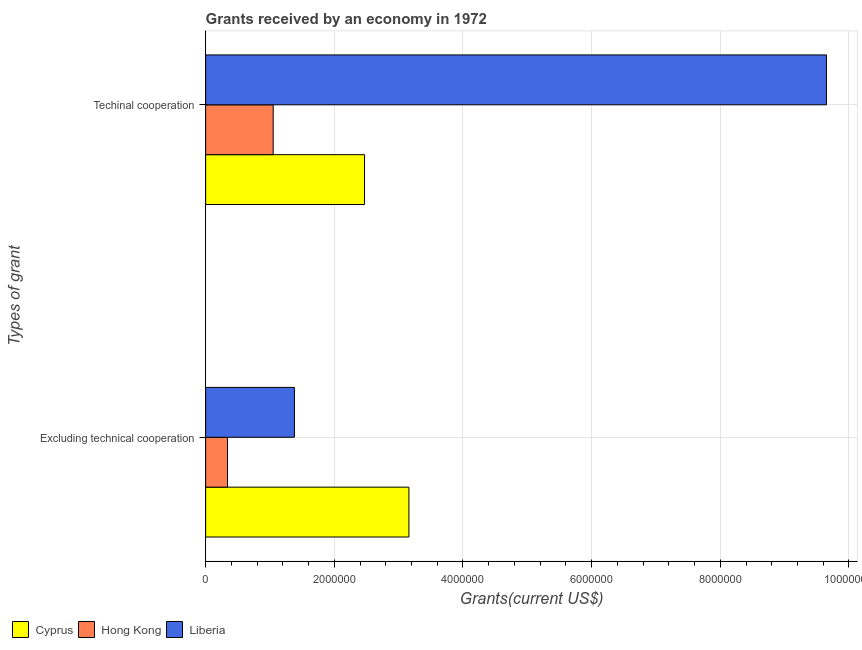How many groups of bars are there?
Make the answer very short. 2. How many bars are there on the 1st tick from the top?
Ensure brevity in your answer.  3. How many bars are there on the 2nd tick from the bottom?
Make the answer very short. 3. What is the label of the 1st group of bars from the top?
Offer a very short reply. Techinal cooperation. What is the amount of grants received(excluding technical cooperation) in Liberia?
Provide a short and direct response. 1.38e+06. Across all countries, what is the maximum amount of grants received(excluding technical cooperation)?
Give a very brief answer. 3.16e+06. Across all countries, what is the minimum amount of grants received(including technical cooperation)?
Your response must be concise. 1.05e+06. In which country was the amount of grants received(including technical cooperation) maximum?
Make the answer very short. Liberia. In which country was the amount of grants received(excluding technical cooperation) minimum?
Your answer should be compact. Hong Kong. What is the total amount of grants received(excluding technical cooperation) in the graph?
Your answer should be very brief. 4.88e+06. What is the difference between the amount of grants received(including technical cooperation) in Hong Kong and that in Cyprus?
Provide a short and direct response. -1.42e+06. What is the difference between the amount of grants received(including technical cooperation) in Cyprus and the amount of grants received(excluding technical cooperation) in Liberia?
Keep it short and to the point. 1.09e+06. What is the average amount of grants received(excluding technical cooperation) per country?
Provide a succinct answer. 1.63e+06. What is the difference between the amount of grants received(excluding technical cooperation) and amount of grants received(including technical cooperation) in Hong Kong?
Provide a succinct answer. -7.10e+05. What is the ratio of the amount of grants received(excluding technical cooperation) in Liberia to that in Hong Kong?
Your answer should be very brief. 4.06. What does the 2nd bar from the top in Excluding technical cooperation represents?
Ensure brevity in your answer.  Hong Kong. What does the 2nd bar from the bottom in Excluding technical cooperation represents?
Make the answer very short. Hong Kong. Are all the bars in the graph horizontal?
Your answer should be very brief. Yes. What is the difference between two consecutive major ticks on the X-axis?
Give a very brief answer. 2.00e+06. Are the values on the major ticks of X-axis written in scientific E-notation?
Offer a terse response. No. Does the graph contain any zero values?
Your answer should be compact. No. Where does the legend appear in the graph?
Provide a short and direct response. Bottom left. How many legend labels are there?
Your answer should be compact. 3. How are the legend labels stacked?
Your answer should be compact. Horizontal. What is the title of the graph?
Give a very brief answer. Grants received by an economy in 1972. Does "Dominica" appear as one of the legend labels in the graph?
Offer a very short reply. No. What is the label or title of the X-axis?
Your response must be concise. Grants(current US$). What is the label or title of the Y-axis?
Make the answer very short. Types of grant. What is the Grants(current US$) in Cyprus in Excluding technical cooperation?
Your answer should be very brief. 3.16e+06. What is the Grants(current US$) of Liberia in Excluding technical cooperation?
Your answer should be compact. 1.38e+06. What is the Grants(current US$) of Cyprus in Techinal cooperation?
Provide a succinct answer. 2.47e+06. What is the Grants(current US$) in Hong Kong in Techinal cooperation?
Make the answer very short. 1.05e+06. What is the Grants(current US$) in Liberia in Techinal cooperation?
Your answer should be compact. 9.65e+06. Across all Types of grant, what is the maximum Grants(current US$) in Cyprus?
Offer a very short reply. 3.16e+06. Across all Types of grant, what is the maximum Grants(current US$) of Hong Kong?
Provide a short and direct response. 1.05e+06. Across all Types of grant, what is the maximum Grants(current US$) of Liberia?
Offer a terse response. 9.65e+06. Across all Types of grant, what is the minimum Grants(current US$) of Cyprus?
Offer a very short reply. 2.47e+06. Across all Types of grant, what is the minimum Grants(current US$) in Liberia?
Give a very brief answer. 1.38e+06. What is the total Grants(current US$) in Cyprus in the graph?
Offer a very short reply. 5.63e+06. What is the total Grants(current US$) in Hong Kong in the graph?
Provide a succinct answer. 1.39e+06. What is the total Grants(current US$) in Liberia in the graph?
Give a very brief answer. 1.10e+07. What is the difference between the Grants(current US$) in Cyprus in Excluding technical cooperation and that in Techinal cooperation?
Provide a short and direct response. 6.90e+05. What is the difference between the Grants(current US$) of Hong Kong in Excluding technical cooperation and that in Techinal cooperation?
Provide a succinct answer. -7.10e+05. What is the difference between the Grants(current US$) in Liberia in Excluding technical cooperation and that in Techinal cooperation?
Make the answer very short. -8.27e+06. What is the difference between the Grants(current US$) of Cyprus in Excluding technical cooperation and the Grants(current US$) of Hong Kong in Techinal cooperation?
Your answer should be very brief. 2.11e+06. What is the difference between the Grants(current US$) in Cyprus in Excluding technical cooperation and the Grants(current US$) in Liberia in Techinal cooperation?
Your answer should be very brief. -6.49e+06. What is the difference between the Grants(current US$) in Hong Kong in Excluding technical cooperation and the Grants(current US$) in Liberia in Techinal cooperation?
Offer a very short reply. -9.31e+06. What is the average Grants(current US$) of Cyprus per Types of grant?
Your response must be concise. 2.82e+06. What is the average Grants(current US$) of Hong Kong per Types of grant?
Keep it short and to the point. 6.95e+05. What is the average Grants(current US$) of Liberia per Types of grant?
Give a very brief answer. 5.52e+06. What is the difference between the Grants(current US$) in Cyprus and Grants(current US$) in Hong Kong in Excluding technical cooperation?
Provide a succinct answer. 2.82e+06. What is the difference between the Grants(current US$) of Cyprus and Grants(current US$) of Liberia in Excluding technical cooperation?
Keep it short and to the point. 1.78e+06. What is the difference between the Grants(current US$) in Hong Kong and Grants(current US$) in Liberia in Excluding technical cooperation?
Provide a succinct answer. -1.04e+06. What is the difference between the Grants(current US$) in Cyprus and Grants(current US$) in Hong Kong in Techinal cooperation?
Your response must be concise. 1.42e+06. What is the difference between the Grants(current US$) in Cyprus and Grants(current US$) in Liberia in Techinal cooperation?
Your answer should be compact. -7.18e+06. What is the difference between the Grants(current US$) in Hong Kong and Grants(current US$) in Liberia in Techinal cooperation?
Provide a short and direct response. -8.60e+06. What is the ratio of the Grants(current US$) in Cyprus in Excluding technical cooperation to that in Techinal cooperation?
Your answer should be very brief. 1.28. What is the ratio of the Grants(current US$) in Hong Kong in Excluding technical cooperation to that in Techinal cooperation?
Your answer should be compact. 0.32. What is the ratio of the Grants(current US$) in Liberia in Excluding technical cooperation to that in Techinal cooperation?
Provide a succinct answer. 0.14. What is the difference between the highest and the second highest Grants(current US$) in Cyprus?
Your answer should be compact. 6.90e+05. What is the difference between the highest and the second highest Grants(current US$) of Hong Kong?
Ensure brevity in your answer.  7.10e+05. What is the difference between the highest and the second highest Grants(current US$) in Liberia?
Give a very brief answer. 8.27e+06. What is the difference between the highest and the lowest Grants(current US$) in Cyprus?
Your answer should be compact. 6.90e+05. What is the difference between the highest and the lowest Grants(current US$) in Hong Kong?
Keep it short and to the point. 7.10e+05. What is the difference between the highest and the lowest Grants(current US$) of Liberia?
Make the answer very short. 8.27e+06. 